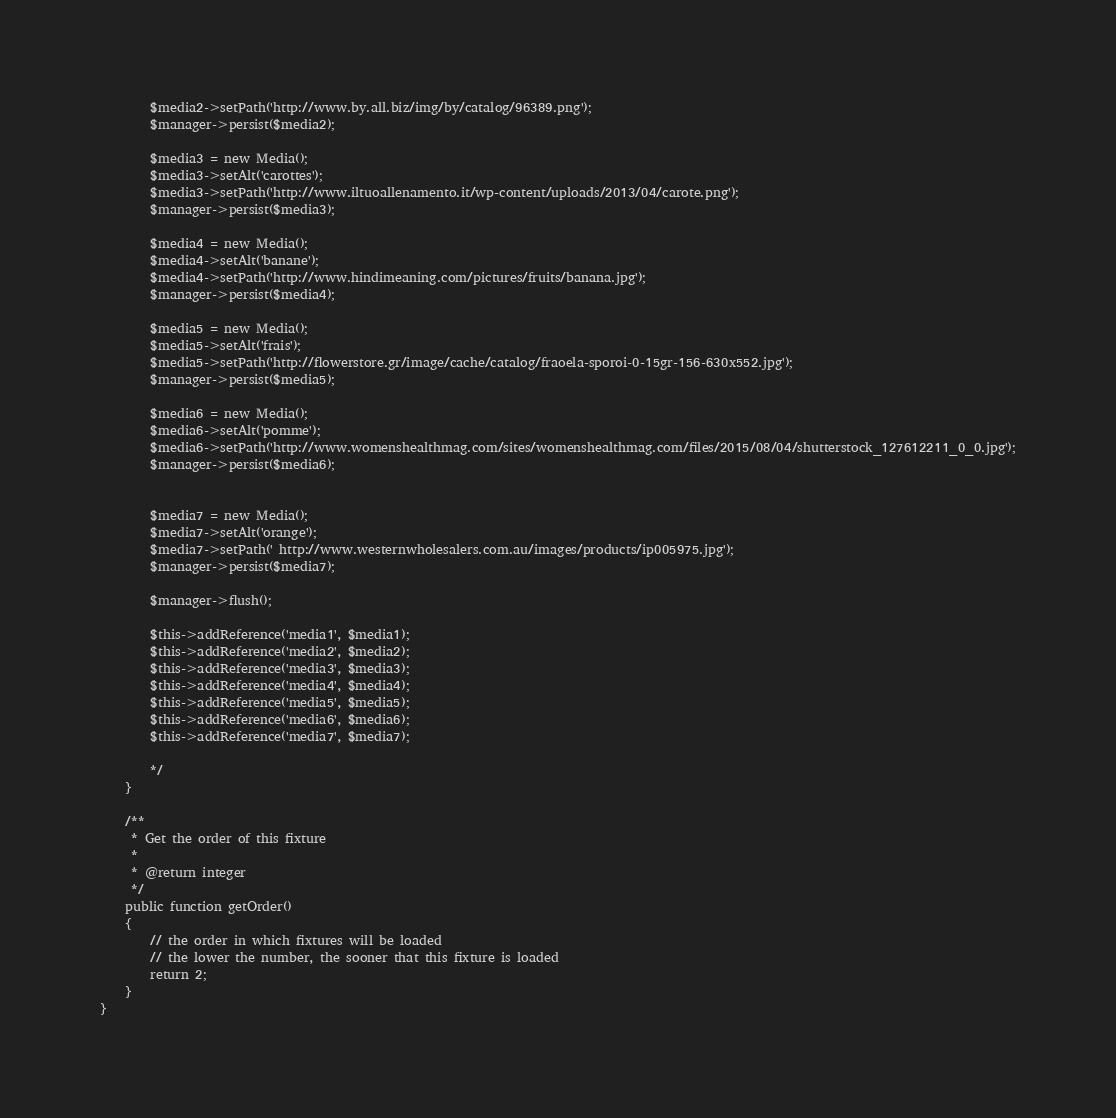Convert code to text. <code><loc_0><loc_0><loc_500><loc_500><_PHP_>        $media2->setPath('http://www.by.all.biz/img/by/catalog/96389.png');
        $manager->persist($media2);

        $media3 = new Media();
        $media3->setAlt('carottes');
        $media3->setPath('http://www.iltuoallenamento.it/wp-content/uploads/2013/04/carote.png');
        $manager->persist($media3);

        $media4 = new Media();
        $media4->setAlt('banane');
        $media4->setPath('http://www.hindimeaning.com/pictures/fruits/banana.jpg');
        $manager->persist($media4);

        $media5 = new Media();
        $media5->setAlt('frais');
        $media5->setPath('http://flowerstore.gr/image/cache/catalog/fraoela-sporoi-0-15gr-156-630x552.jpg');
        $manager->persist($media5);

        $media6 = new Media();
        $media6->setAlt('pomme');
        $media6->setPath('http://www.womenshealthmag.com/sites/womenshealthmag.com/files/2015/08/04/shutterstock_127612211_0_0.jpg');
        $manager->persist($media6);


        $media7 = new Media();
        $media7->setAlt('orange');
        $media7->setPath(' http://www.westernwholesalers.com.au/images/products/ip005975.jpg');
        $manager->persist($media7);

        $manager->flush();

        $this->addReference('media1', $media1);
        $this->addReference('media2', $media2);
        $this->addReference('media3', $media3);
        $this->addReference('media4', $media4);
        $this->addReference('media5', $media5);
        $this->addReference('media6', $media6);
        $this->addReference('media7', $media7);

        */
    }

    /**
     * Get the order of this fixture
     *
     * @return integer
     */
    public function getOrder()
    {
        // the order in which fixtures will be loaded
        // the lower the number, the sooner that this fixture is loaded
        return 2;
    }
}</code> 